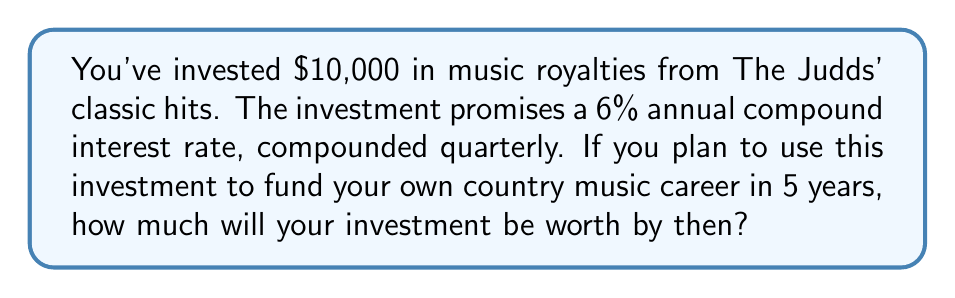Solve this math problem. Let's approach this step-by-step using the compound interest formula:

$$A = P(1 + \frac{r}{n})^{nt}$$

Where:
$A$ = Final amount
$P$ = Principal investment
$r$ = Annual interest rate (in decimal form)
$n$ = Number of times interest is compounded per year
$t$ = Number of years

Given:
$P = 10000$
$r = 0.06$ (6% in decimal form)
$n = 4$ (compounded quarterly, so 4 times per year)
$t = 5$ years

Let's substitute these values into the formula:

$$A = 10000(1 + \frac{0.06}{4})^{4 \times 5}$$

$$A = 10000(1 + 0.015)^{20}$$

$$A = 10000(1.015)^{20}$$

Using a calculator or computer:

$$A = 10000 \times 1.3468738$$

$$A = 13468.74$$

Therefore, after 5 years, your investment will be worth $13,468.74.
Answer: $13,468.74 